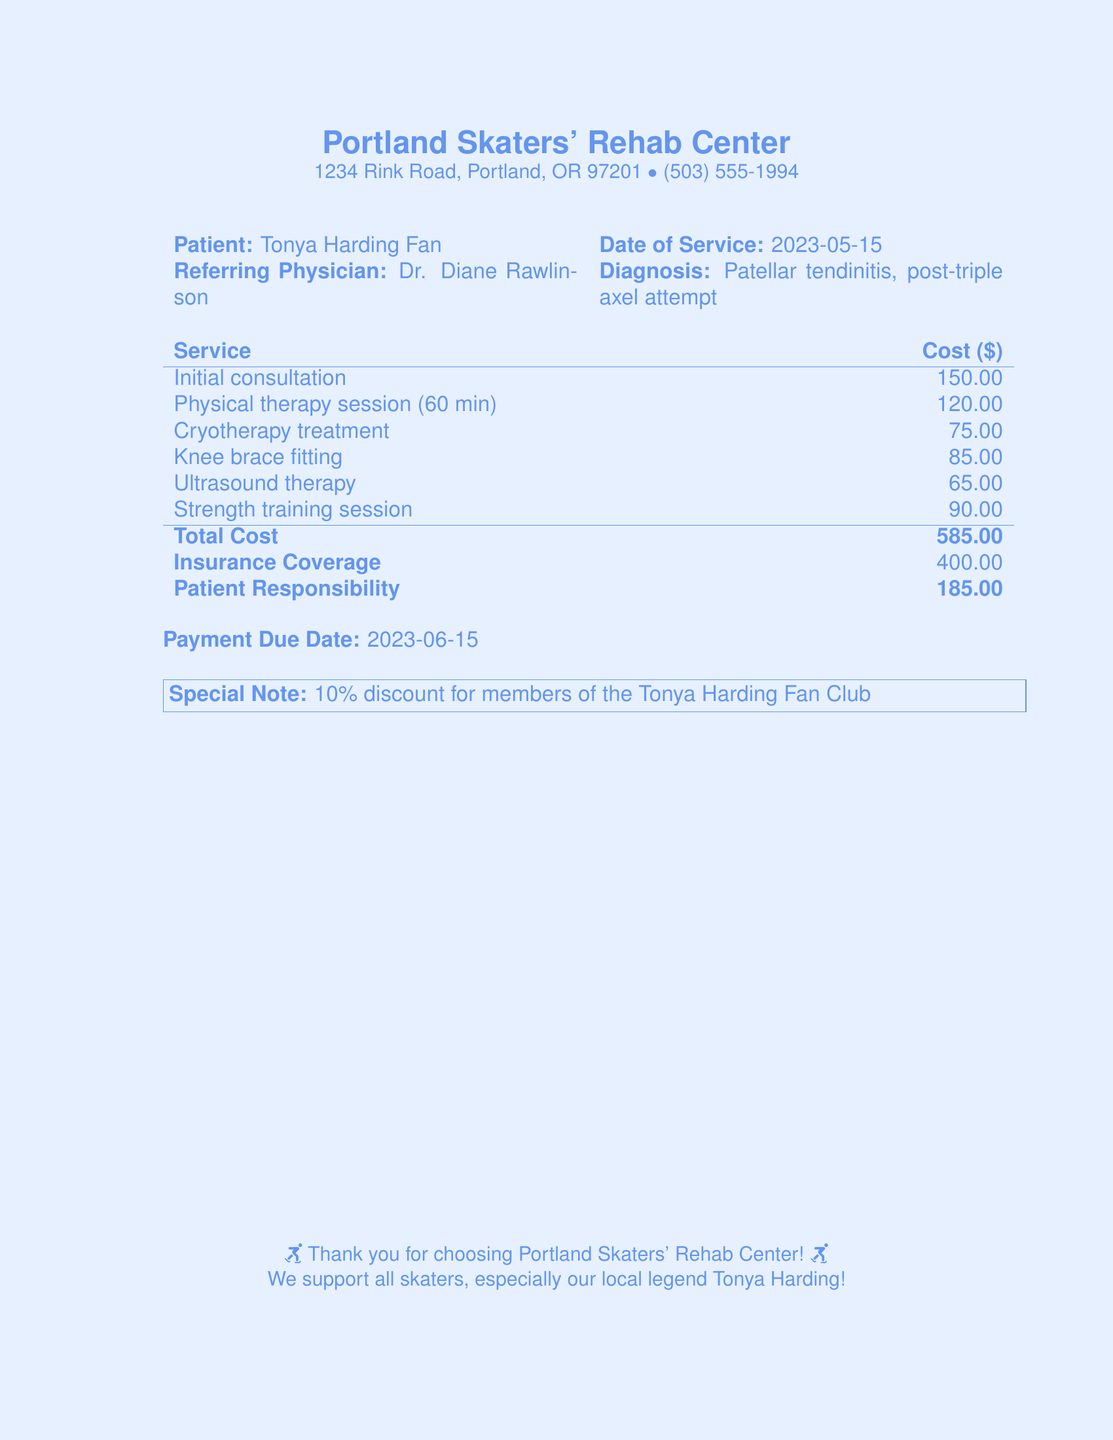What is the patient's name? The patient's name is stated in the document as "Tonya Harding Fan."
Answer: Tonya Harding Fan What is the date of service? The date when the medical services were provided is provided in the document as "2023-05-15."
Answer: 2023-05-15 What is the total cost of services? The total cost is clearly indicated in the document as the final sum of all treatments.
Answer: 585.00 How much is the patient responsible for paying? The document specifies the amount the patient needs to pay after insurance coverage.
Answer: 185.00 What type of treatment did the patient receive for the diagnosis? The diagnosis is "Patellar tendinitis" resulting from a specific skating attempt, and multiple treatments are listed.
Answer: Patellar tendinitis What is the insurance coverage amount? It is necessary to check the document to find how much of the total cost is covered by insurance.
Answer: 400.00 What is the payment due date? This is clearly mentioned in the document as the date by which payment should be made.
Answer: 2023-06-15 Is there a discount mentioned for fan club members? The document includes a special note regarding discounts for particular members.
Answer: Yes, 10% discount Who is the referring physician? The document lists the doctor who referred the patient for treatment.
Answer: Dr. Diane Rawlinson 